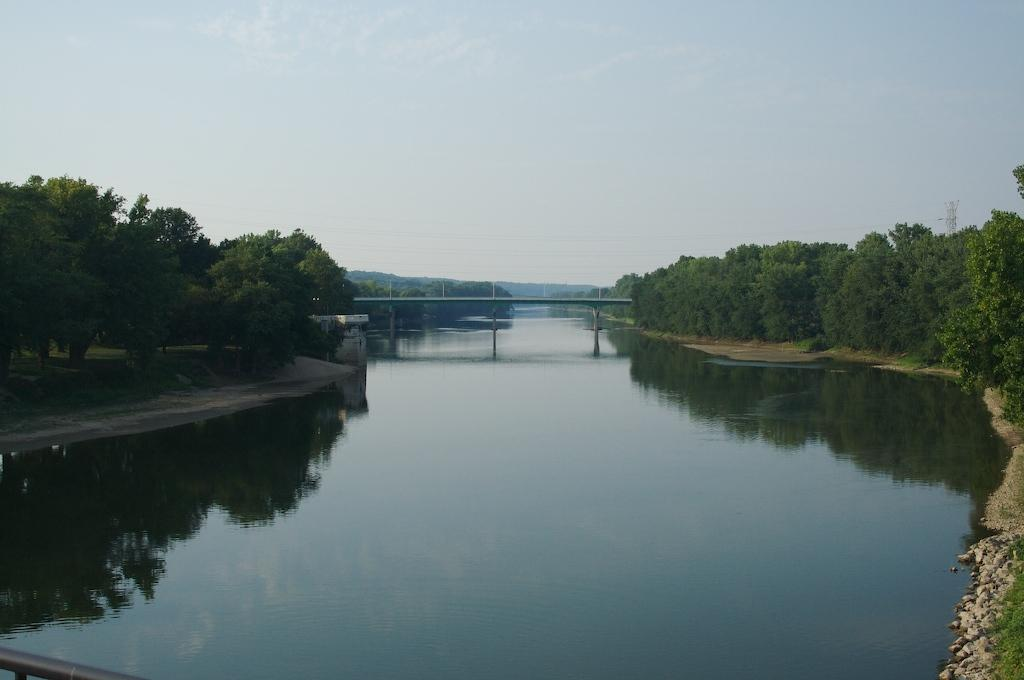What type of structure can be seen in the image? There is a bridge in the image. What is located under the bridge? Water is visible under the bridge. What type of building is present in the image? There is a shed in the image. What type of vegetation can be seen in the image? Trees are present in the image. What else can be seen in the background of the image? Poles and mountains are visible in the background of the image. What is visible in the sky in the image? The sky is visible in the background of the image. What flavor of cabbage is being eaten by the goat in the image? There is no goat or cabbage present in the image. What type of cheese is on the bridge in the image? There is no cheese on the bridge in the image; it is a structure for crossing water. 